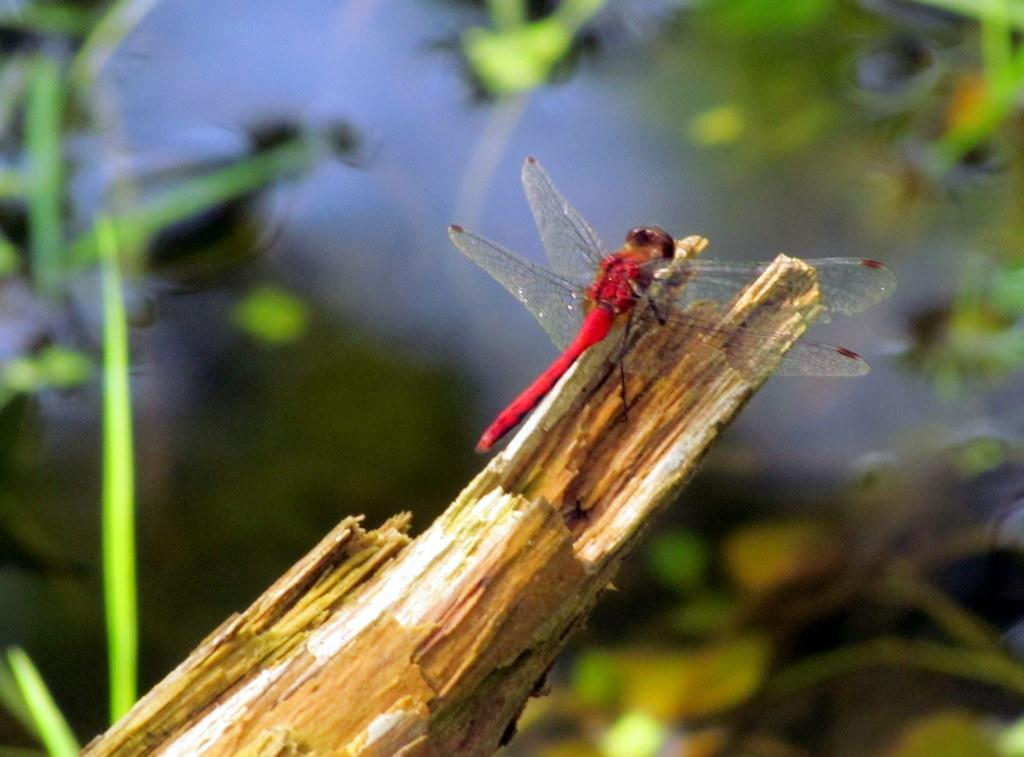What object made of wood can be seen in the image? There is a wooden stick in the image. What type of insect is present in the image? There is a fly in the image. Can you describe the background of the image? The background of the image is blurred. How many letters are visible on the pie in the image? There is no pie or letters present in the image. What type of card is being held by the person in the image? There is no person or card present in the image. 